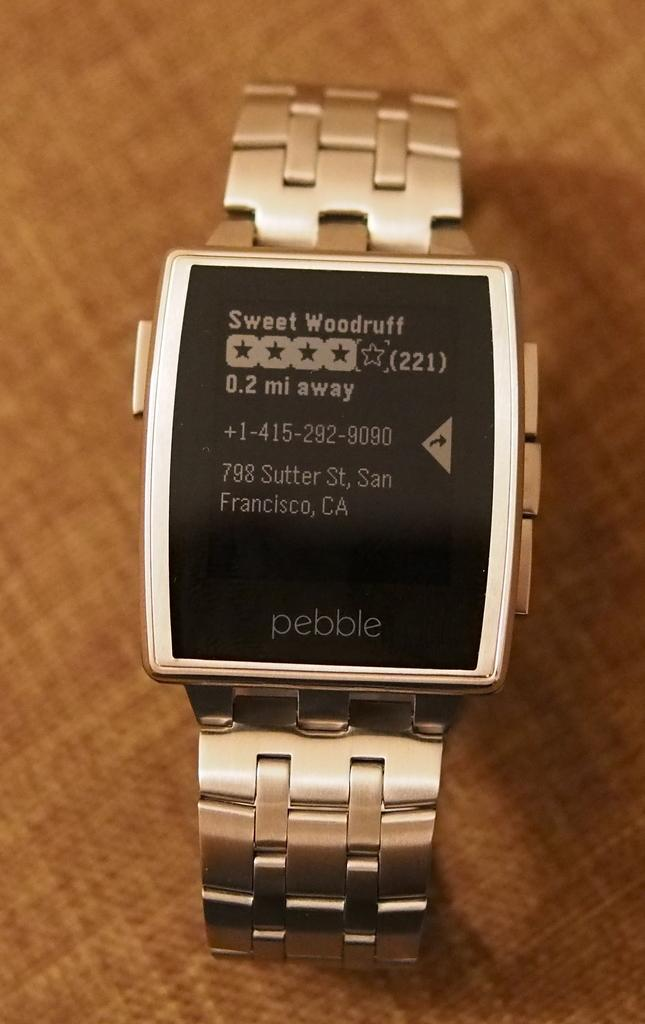What object is the main focus of the image? There is a watch in the image. What can be seen on the watch? The watch has text and numbers displayed on it. What color is the cloth in the background of the image? There is a brown-colored cloth in the background of the image. What hobbies are the flock of birds engaged in while connected to the watch in the image? There are no birds present in the image, and the watch is not connected to any hobbies or flocks of birds. 